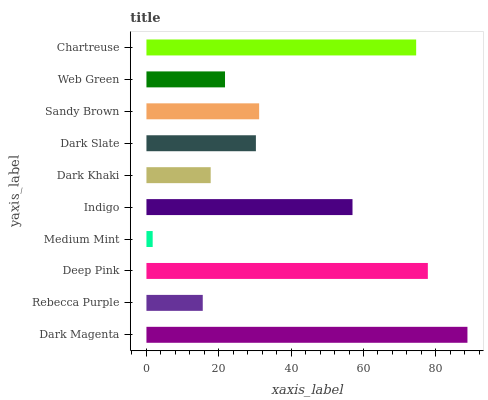Is Medium Mint the minimum?
Answer yes or no. Yes. Is Dark Magenta the maximum?
Answer yes or no. Yes. Is Rebecca Purple the minimum?
Answer yes or no. No. Is Rebecca Purple the maximum?
Answer yes or no. No. Is Dark Magenta greater than Rebecca Purple?
Answer yes or no. Yes. Is Rebecca Purple less than Dark Magenta?
Answer yes or no. Yes. Is Rebecca Purple greater than Dark Magenta?
Answer yes or no. No. Is Dark Magenta less than Rebecca Purple?
Answer yes or no. No. Is Sandy Brown the high median?
Answer yes or no. Yes. Is Dark Slate the low median?
Answer yes or no. Yes. Is Indigo the high median?
Answer yes or no. No. Is Chartreuse the low median?
Answer yes or no. No. 